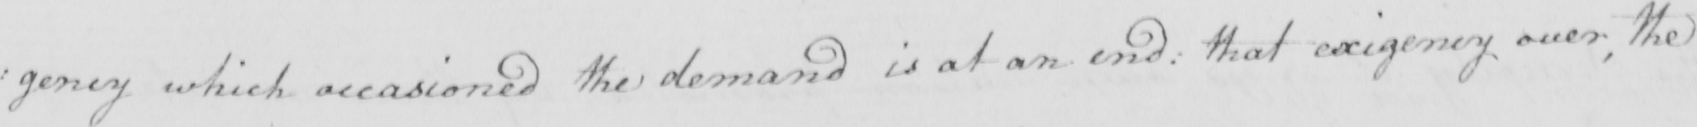What does this handwritten line say? : gency which occasioned the demand is at an end :  that exigency over ; the 